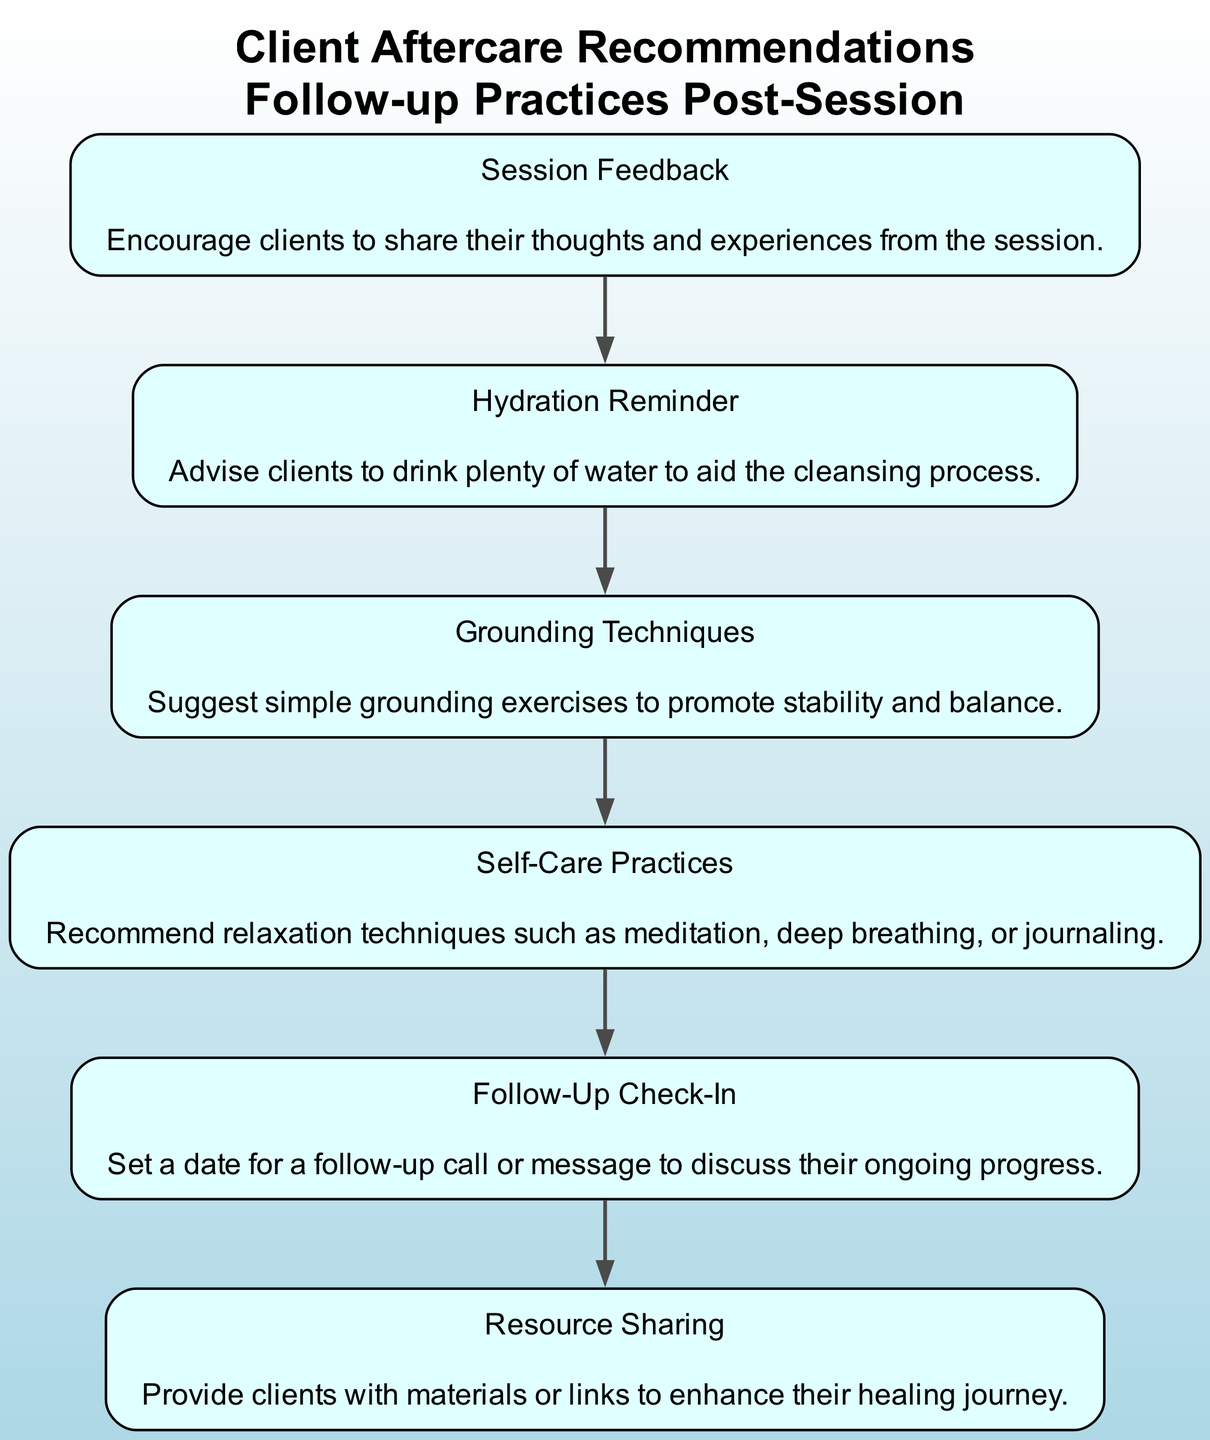What is the first element in the flow chart? The first element listed in the diagram is “Session Feedback.” It is positioned at the topmost node of the flow chart, indicating that it comes first in the sequence of aftercare recommendations.
Answer: Session Feedback How many nodes are present in the flow chart? The diagram consists of six distinct elements or nodes, starting from “Session Feedback” to “Resource Sharing.” Each node represents a separate aftercare recommendation.
Answer: 6 What comes immediately after "Hydration Reminder"? Following “Hydration Reminder,” the next node in the flow chart is “Grounding Techniques.” The arrows connecting the nodes indicate the flow of recommendations, leading from Hydration to Grounding.
Answer: Grounding Techniques Which node suggests using relaxation techniques? The node that recommends relaxation techniques is “Self-Care Practices.” This node is designed to provide clients with various methods for maintaining their wellbeing post-session.
Answer: Self-Care Practices What is the relationship between "Follow-Up Check-In" and "Resource Sharing"? “Follow-Up Check-In” is the second-to-last node before the final node “Resource Sharing.” The flow chart is directional, showing that a follow-up check-in occurs before sharing additional resources.
Answer: Follow-Up Check-In comes before Resource Sharing What does the "Grounding Techniques" node advise clients to do? The “Grounding Techniques” node suggests simple grounding exercises to promote stability and balance, which is indicated in its description.
Answer: Simple grounding exercises What is the last recommendation in the flow chart? The last recommendation in the flow chart is “Resource Sharing.” This is indicated by its position at the bottom of the flow, showing it is the final suggestion for aftercare recommendations.
Answer: Resource Sharing 